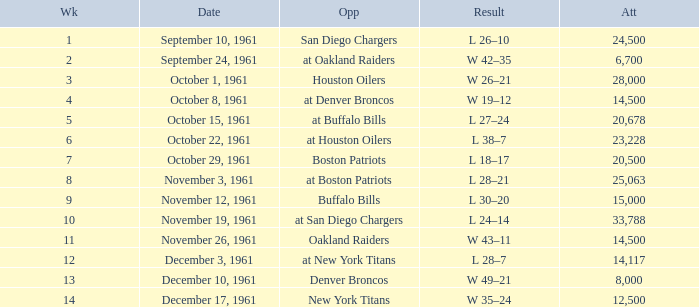Could you help me parse every detail presented in this table? {'header': ['Wk', 'Date', 'Opp', 'Result', 'Att'], 'rows': [['1', 'September 10, 1961', 'San Diego Chargers', 'L 26–10', '24,500'], ['2', 'September 24, 1961', 'at Oakland Raiders', 'W 42–35', '6,700'], ['3', 'October 1, 1961', 'Houston Oilers', 'W 26–21', '28,000'], ['4', 'October 8, 1961', 'at Denver Broncos', 'W 19–12', '14,500'], ['5', 'October 15, 1961', 'at Buffalo Bills', 'L 27–24', '20,678'], ['6', 'October 22, 1961', 'at Houston Oilers', 'L 38–7', '23,228'], ['7', 'October 29, 1961', 'Boston Patriots', 'L 18–17', '20,500'], ['8', 'November 3, 1961', 'at Boston Patriots', 'L 28–21', '25,063'], ['9', 'November 12, 1961', 'Buffalo Bills', 'L 30–20', '15,000'], ['10', 'November 19, 1961', 'at San Diego Chargers', 'L 24–14', '33,788'], ['11', 'November 26, 1961', 'Oakland Raiders', 'W 43–11', '14,500'], ['12', 'December 3, 1961', 'at New York Titans', 'L 28–7', '14,117'], ['13', 'December 10, 1961', 'Denver Broncos', 'W 49–21', '8,000'], ['14', 'December 17, 1961', 'New York Titans', 'W 35–24', '12,500']]} What is the low attendance rate against buffalo bills? 15000.0. 